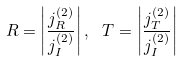<formula> <loc_0><loc_0><loc_500><loc_500>R = \left | \frac { j ^ { ( 2 ) } _ { R } } { j ^ { ( 2 ) } _ { I } } \right | , \ T = \left | \frac { j ^ { ( 2 ) } _ { T } } { j ^ { ( 2 ) } _ { I } } \right |</formula> 